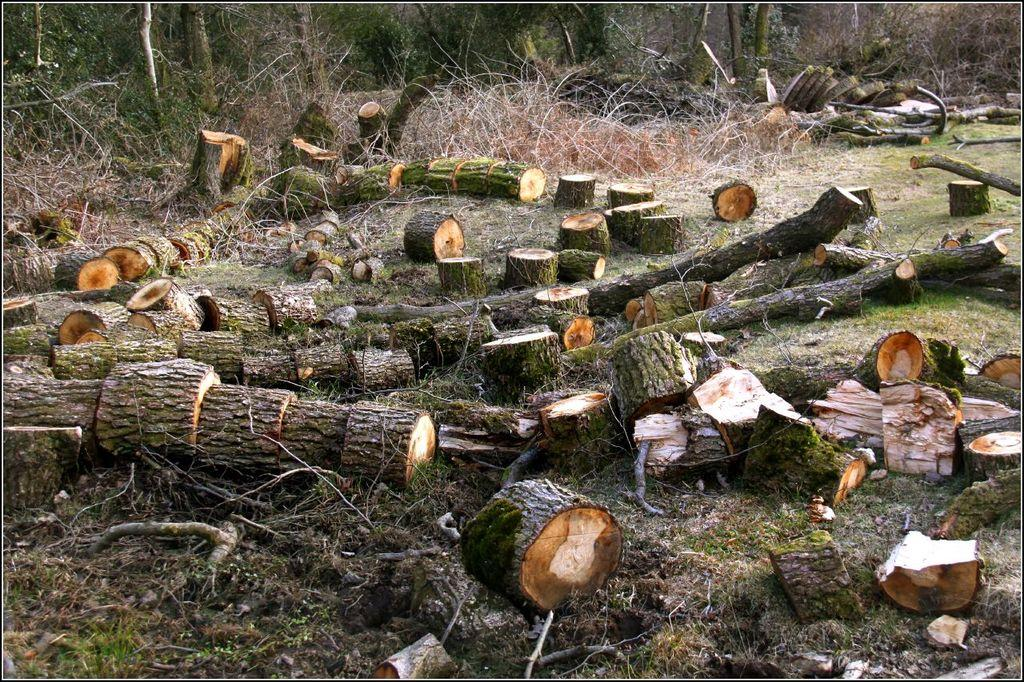What type of natural materials can be seen in the image? There are logs in the image. What type of vegetation is at the bottom of the image? There is grass at the bottom of the image. What can be seen in the background of the image? There are twigs and trees in the background of the image. What type of sound can be heard coming from the children wearing masks in the image? There are no children or masks present in the image, so it is not possible to determine what sound might be heard. 